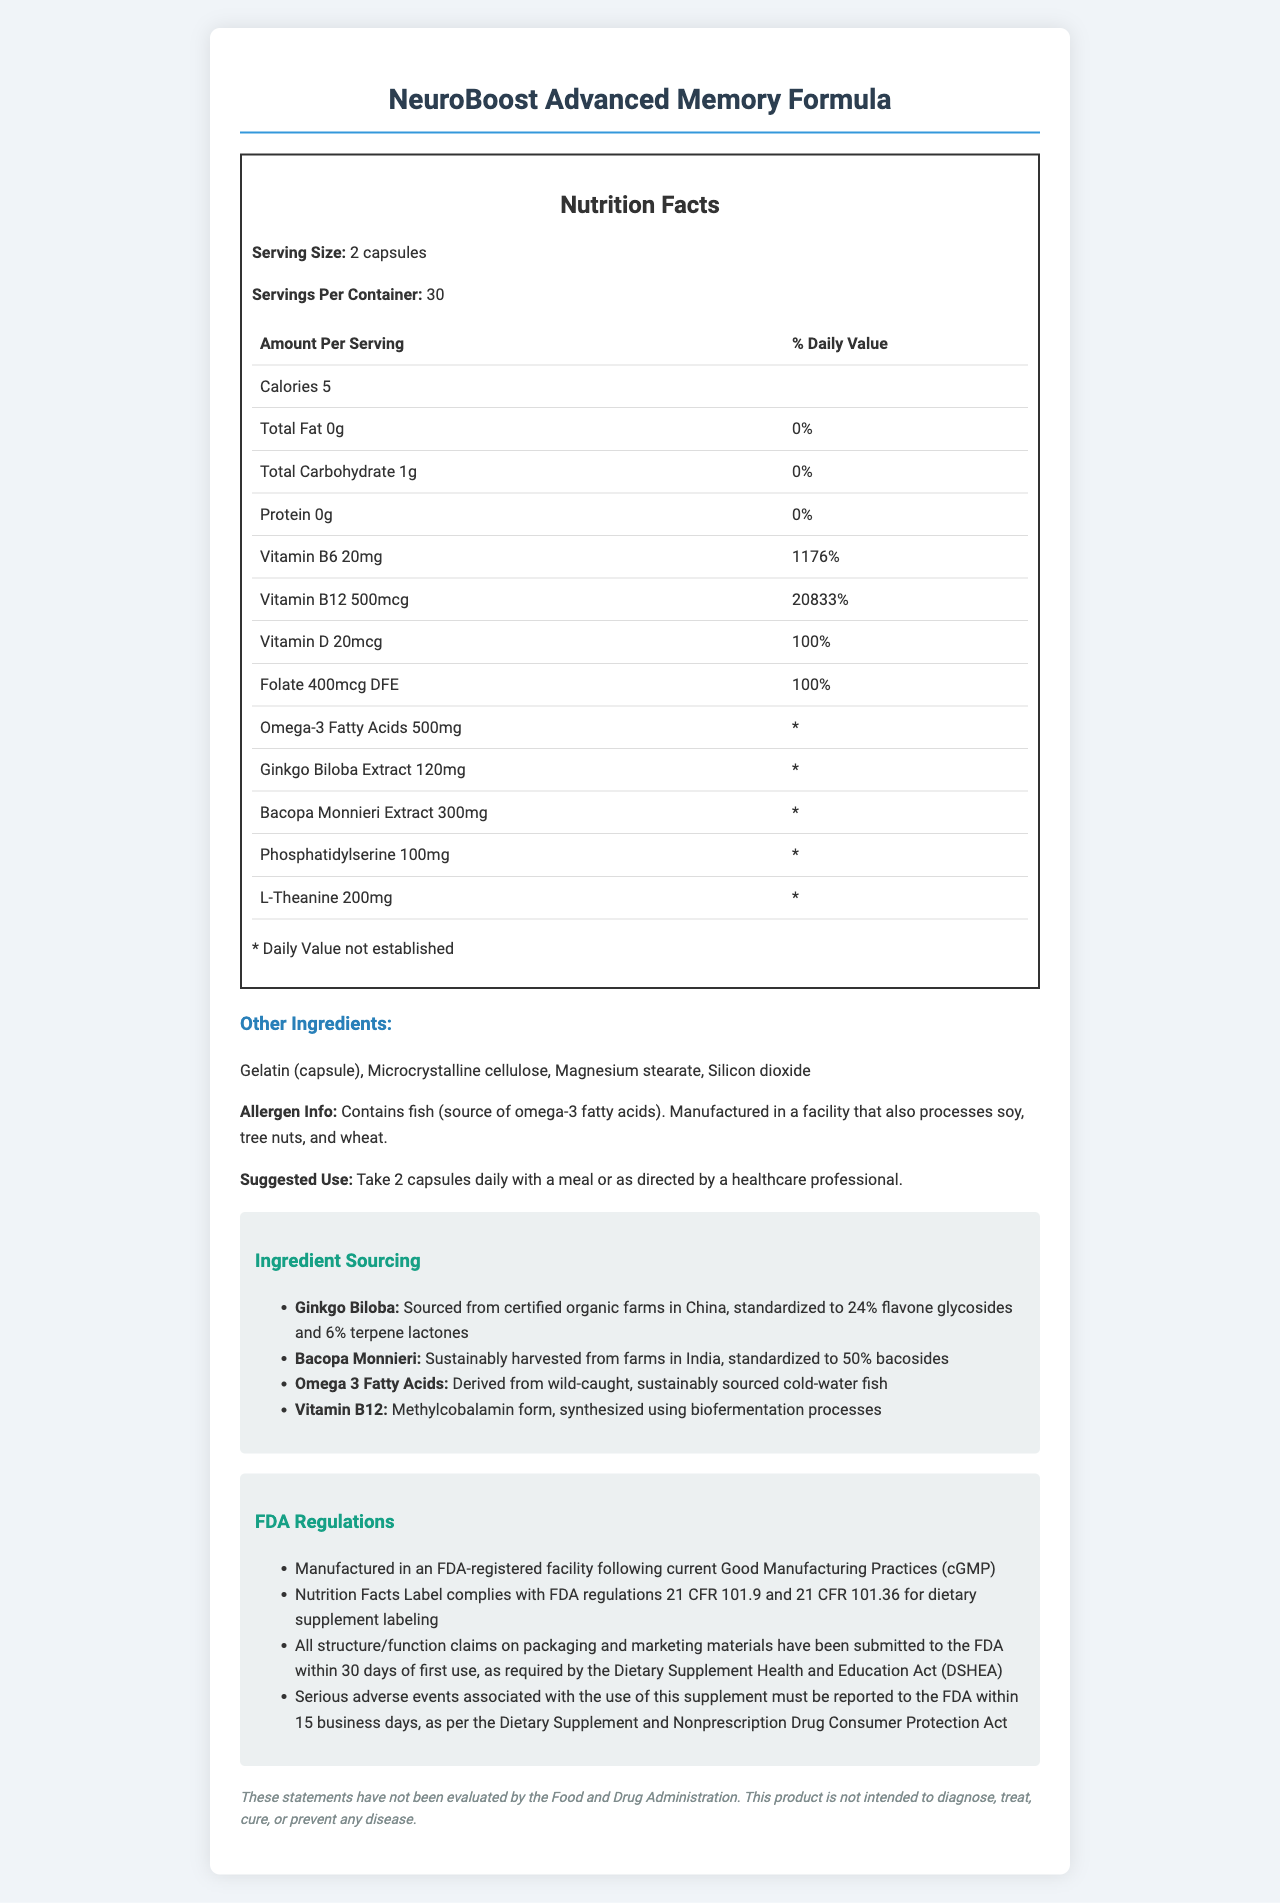what is the serving size for NeuroBoost Advanced Memory Formula? The document states "Serving Size: 2 capsules".
Answer: 2 capsules how many servings are in one container? The document mentions "Servings Per Container: 30".
Answer: 30 how many calories are in a serving? The document lists "Calories: 5".
Answer: 5 does this supplement contain any protein? The document indicates "Protein: 0g".
Answer: No what form of vitamin B12 is used in this supplement? The ingredient sourcing section specifies "Vitamin B12: Methylcobalamin form, synthesized using biofermentation processes".
Answer: Methylcobalamin which ingredient is sourced from China? A. Bacopa Monnieri B. Ginkgo Biloba C. Phosphatidylserine D. L-Theanine The ingredient sourcing section states "Ginkgo Biloba: Sourced from certified organic farms in China".
Answer: B which regulatory compliance is specifically related to manufacturing practices? A. DSHEA B. FTC Guidelines C. cGMP Compliance D. Proposition 65 The FDA regulations section mentions "Manufactured in an FDA-registered facility following current Good Manufacturing Practices (cGMP)".
Answer: C are there any known allergens in the product? The allergen info states "Contains fish (source of omega-3 fatty acids). Manufactured in a facility that also processes soy, tree nuts, and wheat".
Answer: Yes what is the suggested use of the supplement? The document provides this information under the suggested use section.
Answer: Take 2 capsules daily with a meal or as directed by a healthcare professional does this product need a warning label for Proposition 65? The legal considerations section states "This product complies with California's Proposition 65 regulations and does not require a warning label".
Answer: No what are the key components to improve memory and concentration in the supplement? The document lists these as key ingredients targeted for memory and concentration.
Answer: Ginkgo Biloba Extract, Bacopa Monnieri Extract, Phosphatidylserine, L-Theanine how should adverse events be reported? The FDA regulations section outlines "Serious adverse events associated with the use of this supplement must be reported to the FDA within 15 business days".
Answer: To the FDA within 15 business days where is the Bacopa Monnieri extracted from? The ingredient sourcing section mentions "Bacopa Monnieri: Sustainably harvested from farms in India".
Answer: India summarize the key nutritional and regulatory information about NeuroBoost Advanced Memory Formula This summary captures both the nutritional content and regulatory compliance information outlined in the document.
Answer: NeuroBoost Advanced Memory Formula is a dietary supplement designed to improve memory and concentration. Each serving size is 2 capsules, with 30 servings per container. It contains vitamins B6, B12, D, folate, omega-3 fatty acids, ginkgo biloba, bacopa monnieri, phosphatidylserine, and L-theanine. The supplement is free of significant allergens except for fish, and the product is manufactured in compliance with FDA regulations and other legal requirements. what is the FDA's stance on the statements made about this product? The document includes an FDA disclaimer stating, "These statements have not been evaluated by the Food and Drug Administration."
Answer: These statements have not been evaluated by the FDA. how much phosphatidylserine is in each serving? The nutrition label states "Phosphatidylserine: 100mg."
Answer: 100mg which regulatory act requires marketing claims to be submitted to the FDA? The FDA regulations section mentions submission to the FDA "as required by the Dietary Supplement Health and Education Act (DSHEA)".
Answer: The Dietary Supplement Health and Education Act (DSHEA) what scientific form of vitamin B6 is included and in what quantity? The nutrition label lists "Vitamin B6: 20mg."
Answer: Vitamin B6 in the amount of 20mg is the information about the biofermentation process of vitamin B12 available in the document? The document mentions the form and synthesis process of vitamin B12 but does not provide detailed information about the biofermentation process itself.
Answer: No 